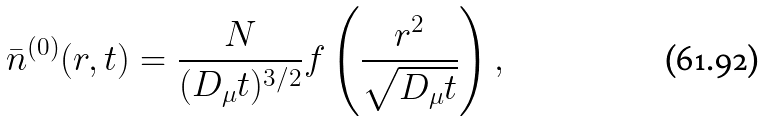<formula> <loc_0><loc_0><loc_500><loc_500>\bar { n } ^ { ( 0 ) } ( r , t ) = \frac { N } { ( D _ { \mu } t ) ^ { 3 / 2 } } f \left ( \frac { r ^ { 2 } } { \sqrt { D _ { \mu } t } } \right ) ,</formula> 